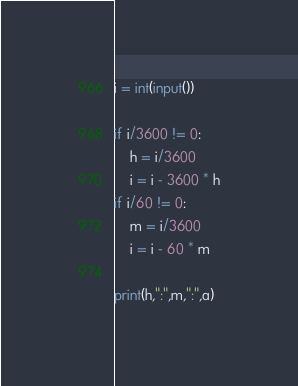Convert code to text. <code><loc_0><loc_0><loc_500><loc_500><_Python_>i = int(input())

if i/3600 != 0:
    h = i/3600
    i = i - 3600 * h
if i/60 != 0:
    m = i/3600
    i = i - 60 * m

print(h,":",m,":",a)
</code> 